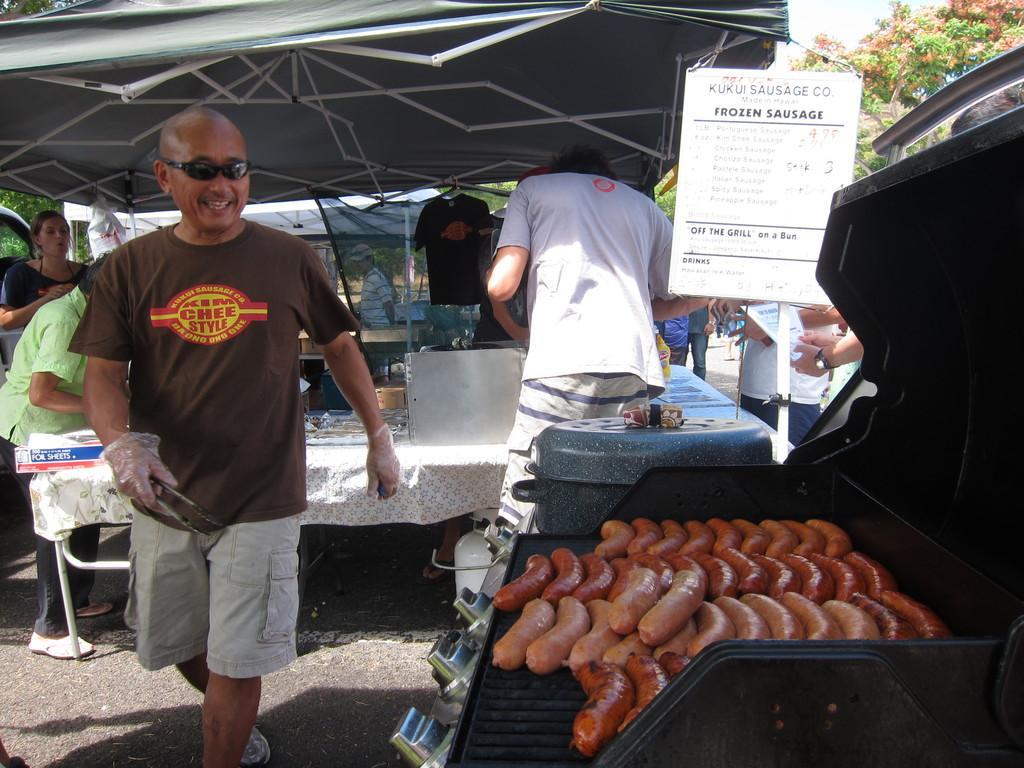Please provide a concise description of this image. In this image I can see few people standing. In front I can see few sausages on the stove. Back I can see few vessels on the table. I can see trees,board and tents. 